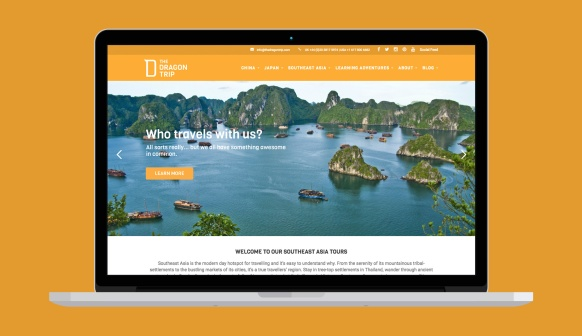What would happen if one of these islands suddenly emerged as the setting for a hidden treasure hunt? Imagine discovering that one of these picturesque islands holds a centuries-old secret - a hidden treasure buried by pirates long ago. Travelers would embark on a thrilling treasure hunt, deciphering ancient maps and puzzling over cryptic clues scattered across the island. The adventure would lead them through dense tropical forests, underwater caves, and historical landmarks. Along the way, they would encounter challenges requiring teamwork and wit to overcome. As the day progresses, the excitement mounts, building up to the climactic discovery of the hidden treasure chest. This treasure hunt, blending adventure, mystery, and history, would make for an unforgettable experience. 